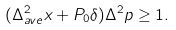Convert formula to latex. <formula><loc_0><loc_0><loc_500><loc_500>( \Delta _ { a v e } ^ { 2 } x + P _ { 0 } \delta ) \Delta ^ { 2 } p \geq 1 .</formula> 